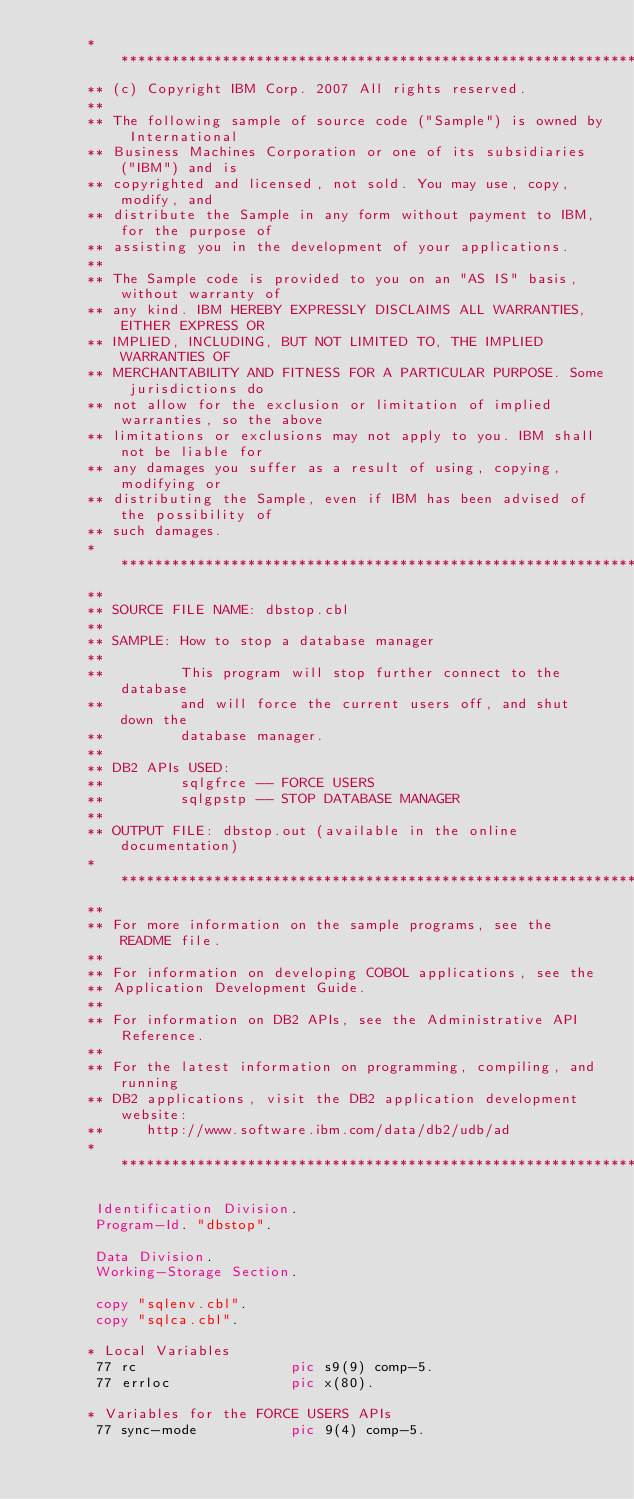<code> <loc_0><loc_0><loc_500><loc_500><_COBOL_>      ***********************************************************************
      ** (c) Copyright IBM Corp. 2007 All rights reserved.
      ** 
      ** The following sample of source code ("Sample") is owned by International 
      ** Business Machines Corporation or one of its subsidiaries ("IBM") and is 
      ** copyrighted and licensed, not sold. You may use, copy, modify, and 
      ** distribute the Sample in any form without payment to IBM, for the purpose of 
      ** assisting you in the development of your applications.
      ** 
      ** The Sample code is provided to you on an "AS IS" basis, without warranty of 
      ** any kind. IBM HEREBY EXPRESSLY DISCLAIMS ALL WARRANTIES, EITHER EXPRESS OR 
      ** IMPLIED, INCLUDING, BUT NOT LIMITED TO, THE IMPLIED WARRANTIES OF 
      ** MERCHANTABILITY AND FITNESS FOR A PARTICULAR PURPOSE. Some jurisdictions do 
      ** not allow for the exclusion or limitation of implied warranties, so the above 
      ** limitations or exclusions may not apply to you. IBM shall not be liable for 
      ** any damages you suffer as a result of using, copying, modifying or 
      ** distributing the Sample, even if IBM has been advised of the possibility of 
      ** such damages.
      ***********************************************************************
      **
      ** SOURCE FILE NAME: dbstop.cbl 
      **
      ** SAMPLE: How to stop a database manager
      **
      **         This program will stop further connect to the database
      **         and will force the current users off, and shut down the
      **         database manager.
      **
      ** DB2 APIs USED:
      **         sqlgfrce -- FORCE USERS
      **         sqlgpstp -- STOP DATABASE MANAGER
      **
      ** OUTPUT FILE: dbstop.out (available in the online documentation)
      ***********************************************************************
      **
      ** For more information on the sample programs, see the README file. 
      **
      ** For information on developing COBOL applications, see the 
      ** Application Development Guide.
      **
      ** For information on DB2 APIs, see the Administrative API Reference.
      **
      ** For the latest information on programming, compiling, and running
      ** DB2 applications, visit the DB2 application development website: 
      **     http://www.software.ibm.com/data/db2/udb/ad
      ***********************************************************************

       Identification Division.
       Program-Id. "dbstop".

       Data Division.
       Working-Storage Section.

       copy "sqlenv.cbl".
       copy "sqlca.cbl".

      * Local Variables
       77 rc                  pic s9(9) comp-5.
       77 errloc              pic x(80).

      * Variables for the FORCE USERS APIs
       77 sync-mode           pic 9(4) comp-5.
</code> 